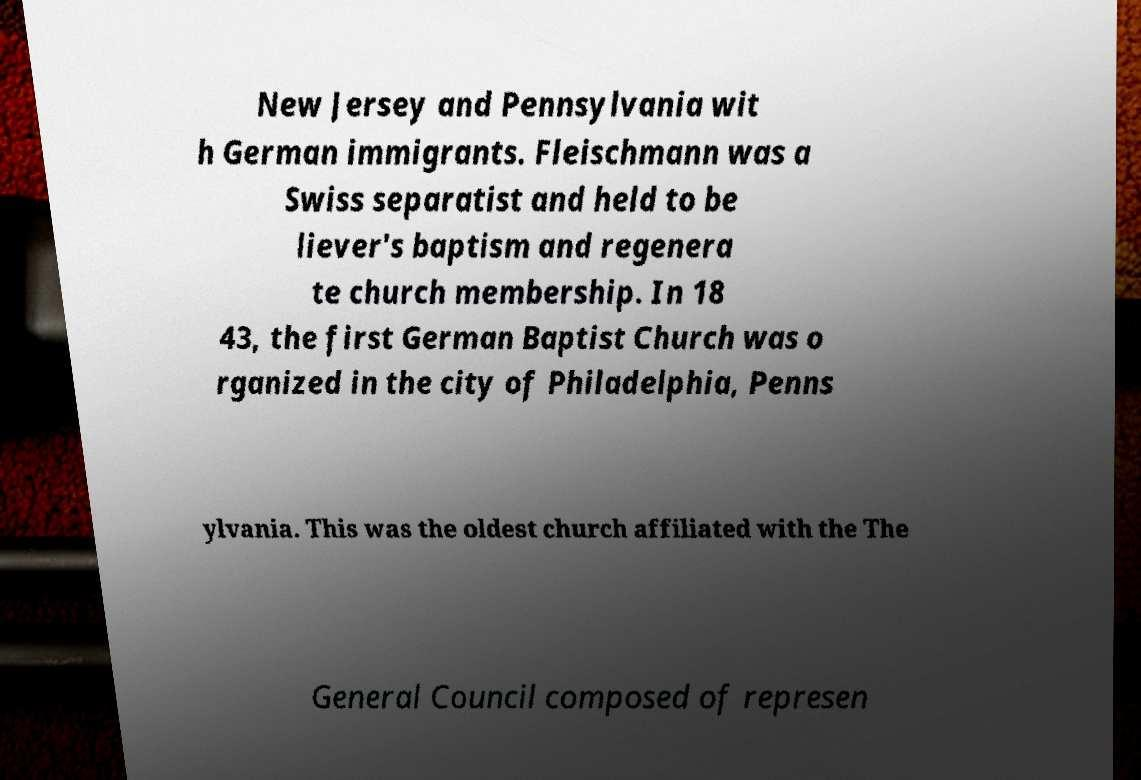What messages or text are displayed in this image? I need them in a readable, typed format. New Jersey and Pennsylvania wit h German immigrants. Fleischmann was a Swiss separatist and held to be liever's baptism and regenera te church membership. In 18 43, the first German Baptist Church was o rganized in the city of Philadelphia, Penns ylvania. This was the oldest church affiliated with the The General Council composed of represen 